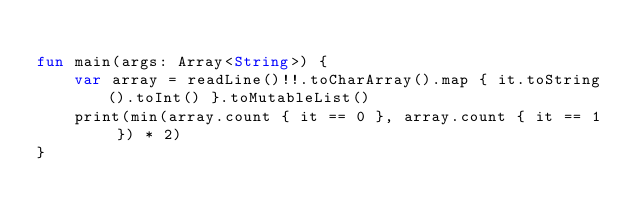Convert code to text. <code><loc_0><loc_0><loc_500><loc_500><_Kotlin_>
fun main(args: Array<String>) {
    var array = readLine()!!.toCharArray().map { it.toString().toInt() }.toMutableList()
    print(min(array.count { it == 0 }, array.count { it == 1 }) * 2)
}

</code> 